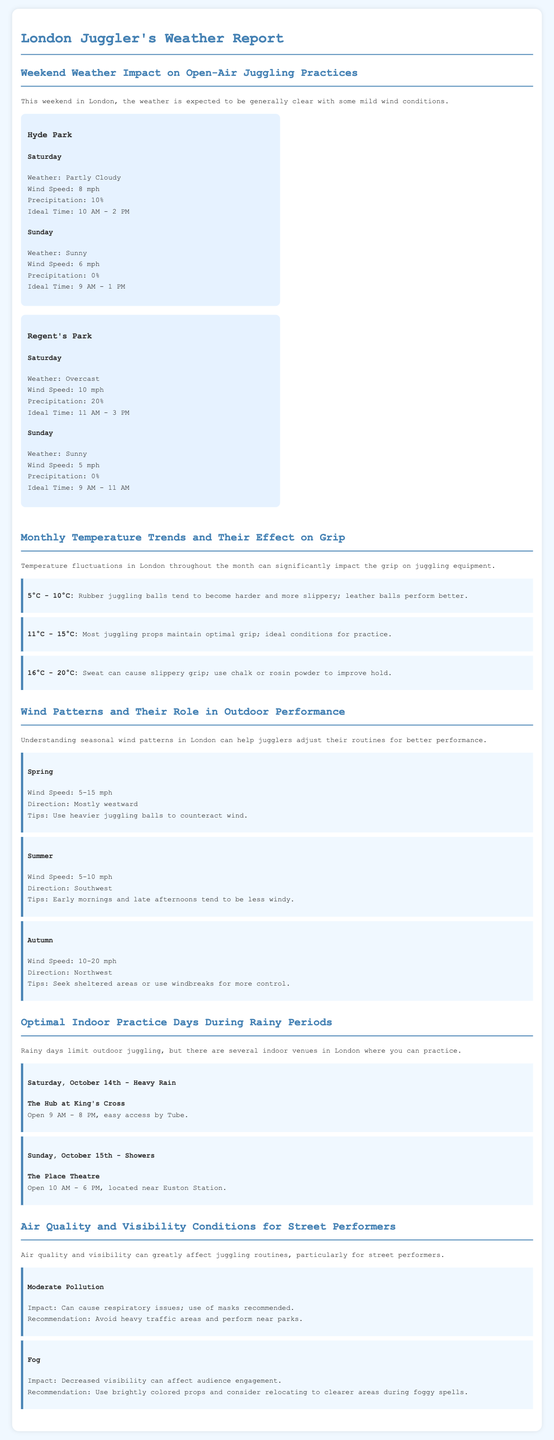What is the weather expected in Hyde Park on Saturday? The weather forecast for Hyde Park on Saturday indicates that it will be partly cloudy.
Answer: Partly Cloudy What is the ideal juggling practice time for Sunday in Regent's Park? The ideal time for juggling practice on Sunday in Regent's Park is 9 AM to 11 AM.
Answer: 9 AM - 11 AM What is the wind speed expected on Sunday in Hyde Park? The wind speed in Hyde Park on Sunday is expected to be 6 mph.
Answer: 6 mph What is the recommended temperature range for optimal grip on juggling equipment? The optimal grip on juggling equipment occurs in the temperature range of 11°C - 15°C.
Answer: 11°C - 15°C What indoor venue is suggested for heavy rain on Saturday? The Hub at King's Cross is the suggested indoor venue for heavy rain on Saturday.
Answer: The Hub at King's Cross What is the suggested action during moderate pollution for street performers? It is recommended that street performers use masks during moderate pollution.
Answer: Use of masks recommended How do wind patterns in autumn affect juggling practices? Wind patterns in autumn can cause juggling speeds of 10-20 mph, and jugglers are advised to seek sheltered areas.
Answer: Seek sheltered areas Which juggling props can become slippery at 16°C - 20°C? Rubber juggling balls tend to become slippery at temperatures between 16°C - 20°C.
Answer: Rubber juggling balls What is the weather condition in London for Sunday? The forecast states that Sunday will be sunny.
Answer: Sunny 